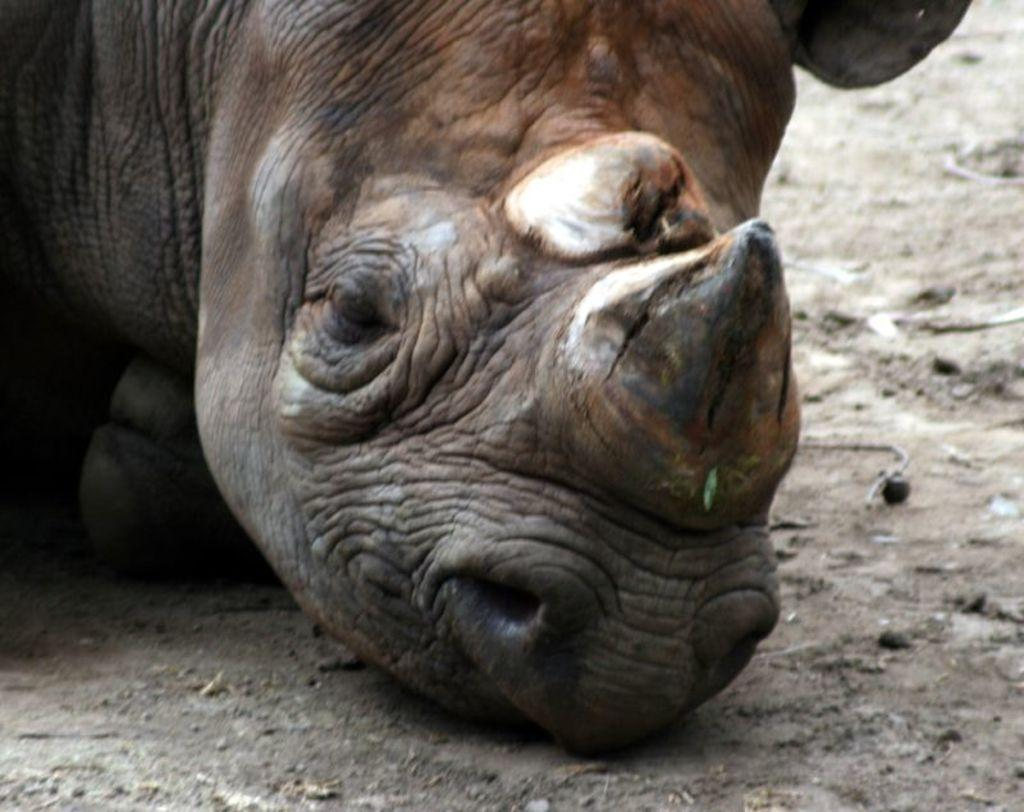What animal is in the center of the image? There is a rhino in the center of the image. What type of surface is visible at the bottom of the image? There is ground visible at the bottom of the image. How do the women in the image express their feelings about the ants? There are no women or ants present in the image, so this question cannot be answered. 